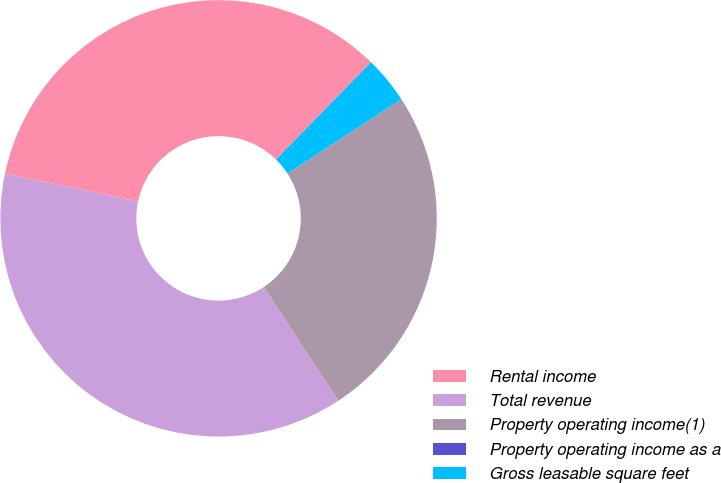<chart> <loc_0><loc_0><loc_500><loc_500><pie_chart><fcel>Rental income<fcel>Total revenue<fcel>Property operating income(1)<fcel>Property operating income as a<fcel>Gross leasable square feet<nl><fcel>34.04%<fcel>37.53%<fcel>24.93%<fcel>0.01%<fcel>3.49%<nl></chart> 